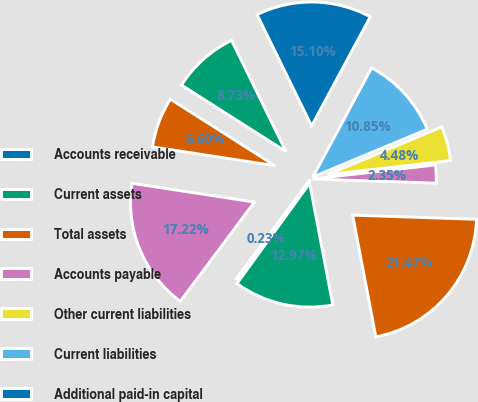<chart> <loc_0><loc_0><loc_500><loc_500><pie_chart><fcel>Accounts receivable<fcel>Current assets<fcel>Total assets<fcel>Accounts payable<fcel>Other current liabilities<fcel>Current liabilities<fcel>Additional paid-in capital<fcel>Accumulated other<fcel>Retained (deficit) earnings<fcel>Total stockholders' equity<nl><fcel>0.23%<fcel>12.97%<fcel>21.47%<fcel>2.35%<fcel>4.48%<fcel>10.85%<fcel>15.1%<fcel>8.73%<fcel>6.6%<fcel>17.22%<nl></chart> 